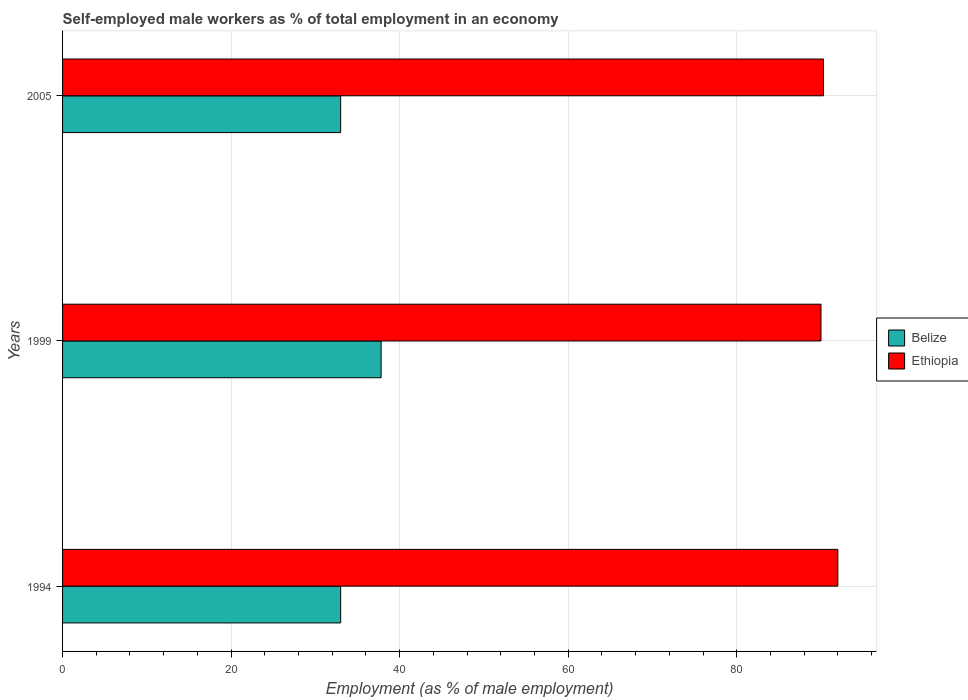How many groups of bars are there?
Keep it short and to the point. 3. Are the number of bars per tick equal to the number of legend labels?
Your answer should be compact. Yes. Are the number of bars on each tick of the Y-axis equal?
Keep it short and to the point. Yes. How many bars are there on the 2nd tick from the top?
Keep it short and to the point. 2. What is the label of the 1st group of bars from the top?
Offer a very short reply. 2005. What is the percentage of self-employed male workers in Belize in 1999?
Offer a very short reply. 37.8. Across all years, what is the maximum percentage of self-employed male workers in Ethiopia?
Your answer should be very brief. 92. Across all years, what is the minimum percentage of self-employed male workers in Ethiopia?
Your answer should be compact. 90. In which year was the percentage of self-employed male workers in Belize maximum?
Offer a terse response. 1999. In which year was the percentage of self-employed male workers in Belize minimum?
Keep it short and to the point. 1994. What is the total percentage of self-employed male workers in Ethiopia in the graph?
Offer a terse response. 272.3. What is the difference between the percentage of self-employed male workers in Belize in 1994 and that in 1999?
Offer a terse response. -4.8. What is the difference between the percentage of self-employed male workers in Ethiopia in 2005 and the percentage of self-employed male workers in Belize in 1999?
Offer a very short reply. 52.5. What is the average percentage of self-employed male workers in Belize per year?
Keep it short and to the point. 34.6. In the year 1994, what is the difference between the percentage of self-employed male workers in Belize and percentage of self-employed male workers in Ethiopia?
Give a very brief answer. -59. What is the ratio of the percentage of self-employed male workers in Belize in 1994 to that in 1999?
Offer a very short reply. 0.87. Is the percentage of self-employed male workers in Belize in 1999 less than that in 2005?
Keep it short and to the point. No. Is the difference between the percentage of self-employed male workers in Belize in 1999 and 2005 greater than the difference between the percentage of self-employed male workers in Ethiopia in 1999 and 2005?
Your response must be concise. Yes. What is the difference between the highest and the second highest percentage of self-employed male workers in Ethiopia?
Make the answer very short. 1.7. Is the sum of the percentage of self-employed male workers in Ethiopia in 1994 and 1999 greater than the maximum percentage of self-employed male workers in Belize across all years?
Your response must be concise. Yes. What does the 1st bar from the top in 2005 represents?
Make the answer very short. Ethiopia. What does the 1st bar from the bottom in 2005 represents?
Provide a succinct answer. Belize. Are all the bars in the graph horizontal?
Ensure brevity in your answer.  Yes. Where does the legend appear in the graph?
Your answer should be very brief. Center right. What is the title of the graph?
Offer a terse response. Self-employed male workers as % of total employment in an economy. Does "Gambia, The" appear as one of the legend labels in the graph?
Your answer should be very brief. No. What is the label or title of the X-axis?
Offer a terse response. Employment (as % of male employment). What is the label or title of the Y-axis?
Provide a short and direct response. Years. What is the Employment (as % of male employment) in Belize in 1994?
Your answer should be very brief. 33. What is the Employment (as % of male employment) in Ethiopia in 1994?
Your answer should be compact. 92. What is the Employment (as % of male employment) in Belize in 1999?
Offer a terse response. 37.8. What is the Employment (as % of male employment) in Ethiopia in 1999?
Keep it short and to the point. 90. What is the Employment (as % of male employment) of Ethiopia in 2005?
Ensure brevity in your answer.  90.3. Across all years, what is the maximum Employment (as % of male employment) in Belize?
Ensure brevity in your answer.  37.8. Across all years, what is the maximum Employment (as % of male employment) of Ethiopia?
Your response must be concise. 92. Across all years, what is the minimum Employment (as % of male employment) of Belize?
Ensure brevity in your answer.  33. What is the total Employment (as % of male employment) of Belize in the graph?
Keep it short and to the point. 103.8. What is the total Employment (as % of male employment) of Ethiopia in the graph?
Provide a succinct answer. 272.3. What is the difference between the Employment (as % of male employment) of Ethiopia in 1994 and that in 2005?
Your response must be concise. 1.7. What is the difference between the Employment (as % of male employment) in Ethiopia in 1999 and that in 2005?
Provide a succinct answer. -0.3. What is the difference between the Employment (as % of male employment) in Belize in 1994 and the Employment (as % of male employment) in Ethiopia in 1999?
Ensure brevity in your answer.  -57. What is the difference between the Employment (as % of male employment) in Belize in 1994 and the Employment (as % of male employment) in Ethiopia in 2005?
Offer a very short reply. -57.3. What is the difference between the Employment (as % of male employment) in Belize in 1999 and the Employment (as % of male employment) in Ethiopia in 2005?
Your answer should be compact. -52.5. What is the average Employment (as % of male employment) of Belize per year?
Offer a terse response. 34.6. What is the average Employment (as % of male employment) in Ethiopia per year?
Provide a succinct answer. 90.77. In the year 1994, what is the difference between the Employment (as % of male employment) of Belize and Employment (as % of male employment) of Ethiopia?
Offer a very short reply. -59. In the year 1999, what is the difference between the Employment (as % of male employment) of Belize and Employment (as % of male employment) of Ethiopia?
Give a very brief answer. -52.2. In the year 2005, what is the difference between the Employment (as % of male employment) of Belize and Employment (as % of male employment) of Ethiopia?
Give a very brief answer. -57.3. What is the ratio of the Employment (as % of male employment) of Belize in 1994 to that in 1999?
Your response must be concise. 0.87. What is the ratio of the Employment (as % of male employment) of Ethiopia in 1994 to that in 1999?
Offer a very short reply. 1.02. What is the ratio of the Employment (as % of male employment) in Ethiopia in 1994 to that in 2005?
Your answer should be very brief. 1.02. What is the ratio of the Employment (as % of male employment) of Belize in 1999 to that in 2005?
Give a very brief answer. 1.15. What is the ratio of the Employment (as % of male employment) of Ethiopia in 1999 to that in 2005?
Provide a short and direct response. 1. What is the difference between the highest and the second highest Employment (as % of male employment) in Belize?
Offer a terse response. 4.8. What is the difference between the highest and the lowest Employment (as % of male employment) in Ethiopia?
Ensure brevity in your answer.  2. 